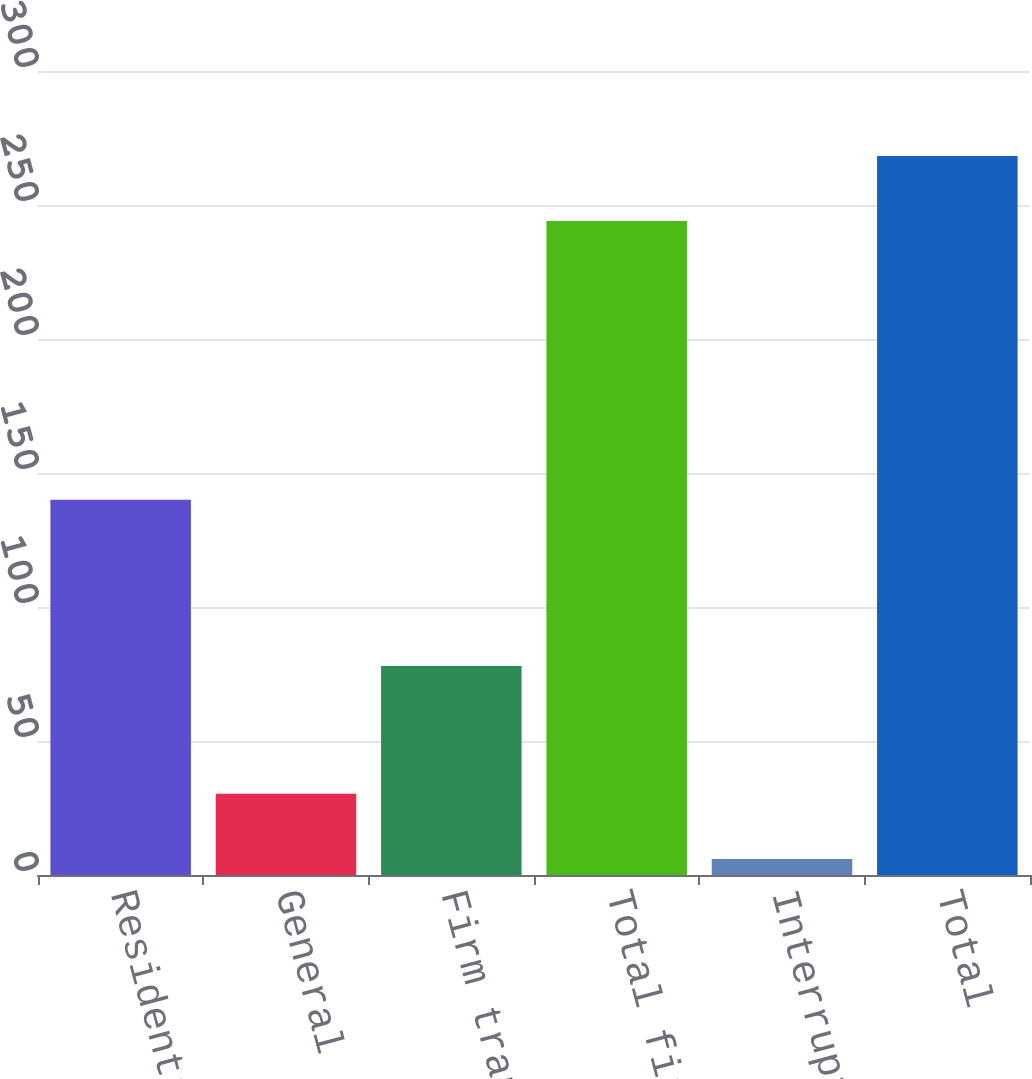Convert chart to OTSL. <chart><loc_0><loc_0><loc_500><loc_500><bar_chart><fcel>Residential<fcel>General<fcel>Firm transportation<fcel>Total firm sales and<fcel>Interruptible sales<fcel>Total<nl><fcel>140<fcel>30.3<fcel>78<fcel>244<fcel>6<fcel>268.3<nl></chart> 